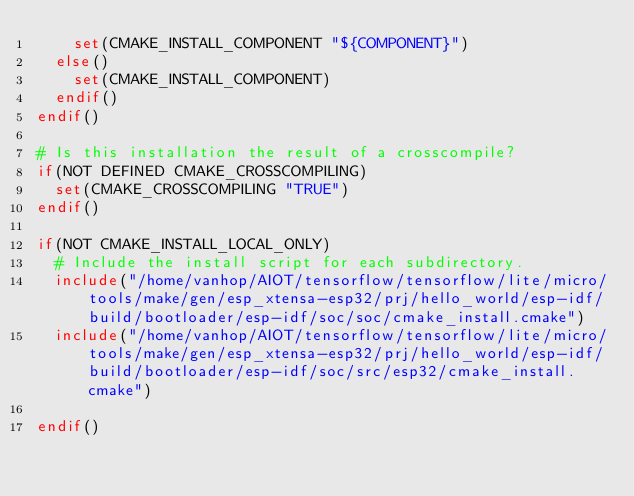<code> <loc_0><loc_0><loc_500><loc_500><_CMake_>    set(CMAKE_INSTALL_COMPONENT "${COMPONENT}")
  else()
    set(CMAKE_INSTALL_COMPONENT)
  endif()
endif()

# Is this installation the result of a crosscompile?
if(NOT DEFINED CMAKE_CROSSCOMPILING)
  set(CMAKE_CROSSCOMPILING "TRUE")
endif()

if(NOT CMAKE_INSTALL_LOCAL_ONLY)
  # Include the install script for each subdirectory.
  include("/home/vanhop/AIOT/tensorflow/tensorflow/lite/micro/tools/make/gen/esp_xtensa-esp32/prj/hello_world/esp-idf/build/bootloader/esp-idf/soc/soc/cmake_install.cmake")
  include("/home/vanhop/AIOT/tensorflow/tensorflow/lite/micro/tools/make/gen/esp_xtensa-esp32/prj/hello_world/esp-idf/build/bootloader/esp-idf/soc/src/esp32/cmake_install.cmake")

endif()

</code> 